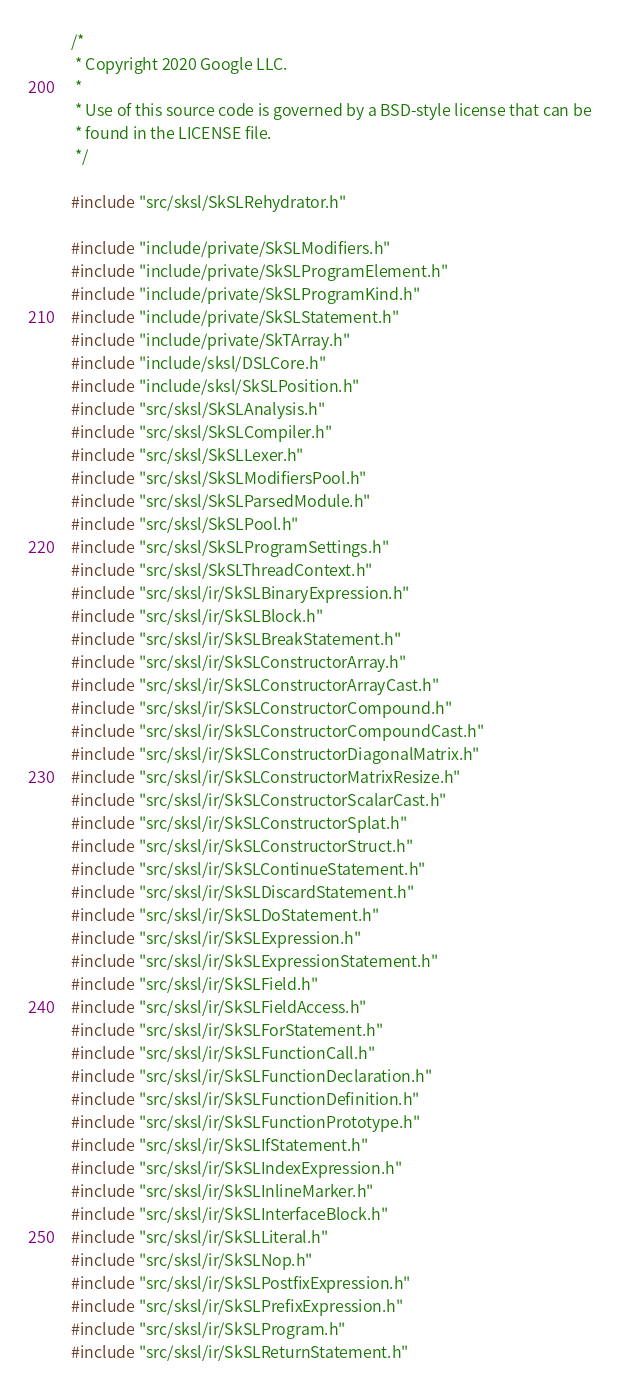<code> <loc_0><loc_0><loc_500><loc_500><_C++_>/*
 * Copyright 2020 Google LLC.
 *
 * Use of this source code is governed by a BSD-style license that can be
 * found in the LICENSE file.
 */

#include "src/sksl/SkSLRehydrator.h"

#include "include/private/SkSLModifiers.h"
#include "include/private/SkSLProgramElement.h"
#include "include/private/SkSLProgramKind.h"
#include "include/private/SkSLStatement.h"
#include "include/private/SkTArray.h"
#include "include/sksl/DSLCore.h"
#include "include/sksl/SkSLPosition.h"
#include "src/sksl/SkSLAnalysis.h"
#include "src/sksl/SkSLCompiler.h"
#include "src/sksl/SkSLLexer.h"
#include "src/sksl/SkSLModifiersPool.h"
#include "src/sksl/SkSLParsedModule.h"
#include "src/sksl/SkSLPool.h"
#include "src/sksl/SkSLProgramSettings.h"
#include "src/sksl/SkSLThreadContext.h"
#include "src/sksl/ir/SkSLBinaryExpression.h"
#include "src/sksl/ir/SkSLBlock.h"
#include "src/sksl/ir/SkSLBreakStatement.h"
#include "src/sksl/ir/SkSLConstructorArray.h"
#include "src/sksl/ir/SkSLConstructorArrayCast.h"
#include "src/sksl/ir/SkSLConstructorCompound.h"
#include "src/sksl/ir/SkSLConstructorCompoundCast.h"
#include "src/sksl/ir/SkSLConstructorDiagonalMatrix.h"
#include "src/sksl/ir/SkSLConstructorMatrixResize.h"
#include "src/sksl/ir/SkSLConstructorScalarCast.h"
#include "src/sksl/ir/SkSLConstructorSplat.h"
#include "src/sksl/ir/SkSLConstructorStruct.h"
#include "src/sksl/ir/SkSLContinueStatement.h"
#include "src/sksl/ir/SkSLDiscardStatement.h"
#include "src/sksl/ir/SkSLDoStatement.h"
#include "src/sksl/ir/SkSLExpression.h"
#include "src/sksl/ir/SkSLExpressionStatement.h"
#include "src/sksl/ir/SkSLField.h"
#include "src/sksl/ir/SkSLFieldAccess.h"
#include "src/sksl/ir/SkSLForStatement.h"
#include "src/sksl/ir/SkSLFunctionCall.h"
#include "src/sksl/ir/SkSLFunctionDeclaration.h"
#include "src/sksl/ir/SkSLFunctionDefinition.h"
#include "src/sksl/ir/SkSLFunctionPrototype.h"
#include "src/sksl/ir/SkSLIfStatement.h"
#include "src/sksl/ir/SkSLIndexExpression.h"
#include "src/sksl/ir/SkSLInlineMarker.h"
#include "src/sksl/ir/SkSLInterfaceBlock.h"
#include "src/sksl/ir/SkSLLiteral.h"
#include "src/sksl/ir/SkSLNop.h"
#include "src/sksl/ir/SkSLPostfixExpression.h"
#include "src/sksl/ir/SkSLPrefixExpression.h"
#include "src/sksl/ir/SkSLProgram.h"
#include "src/sksl/ir/SkSLReturnStatement.h"</code> 